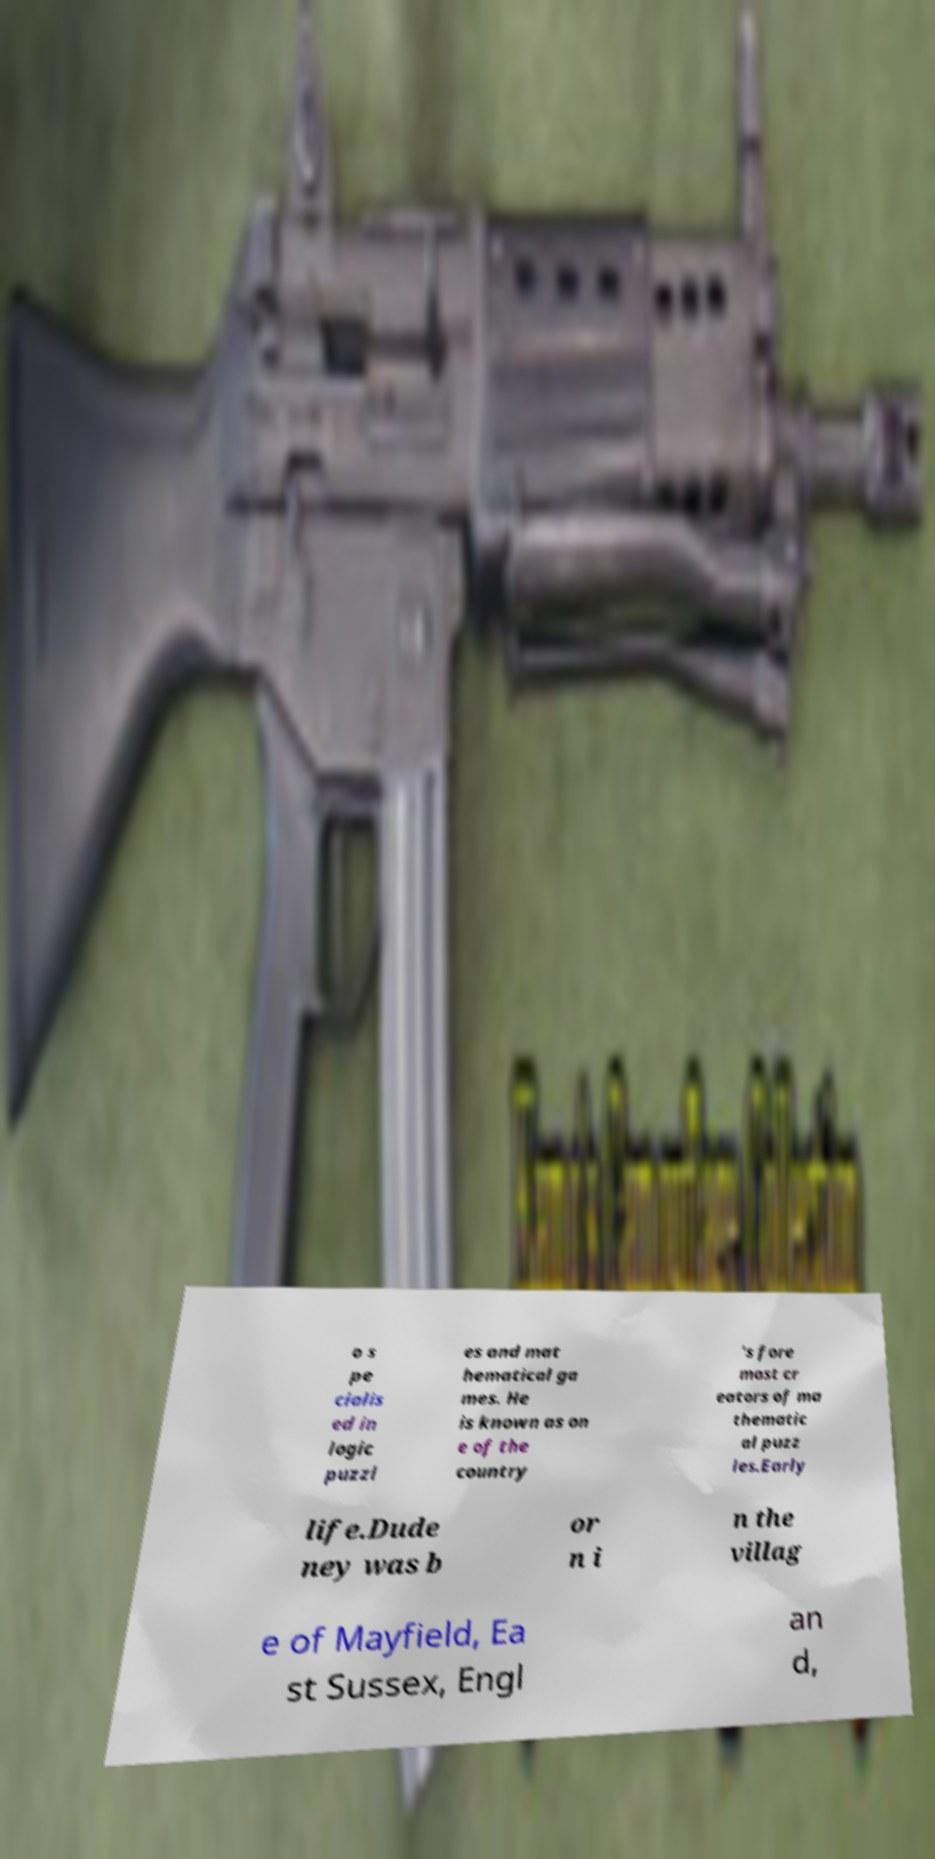What messages or text are displayed in this image? I need them in a readable, typed format. o s pe cialis ed in logic puzzl es and mat hematical ga mes. He is known as on e of the country 's fore most cr eators of ma thematic al puzz les.Early life.Dude ney was b or n i n the villag e of Mayfield, Ea st Sussex, Engl an d, 